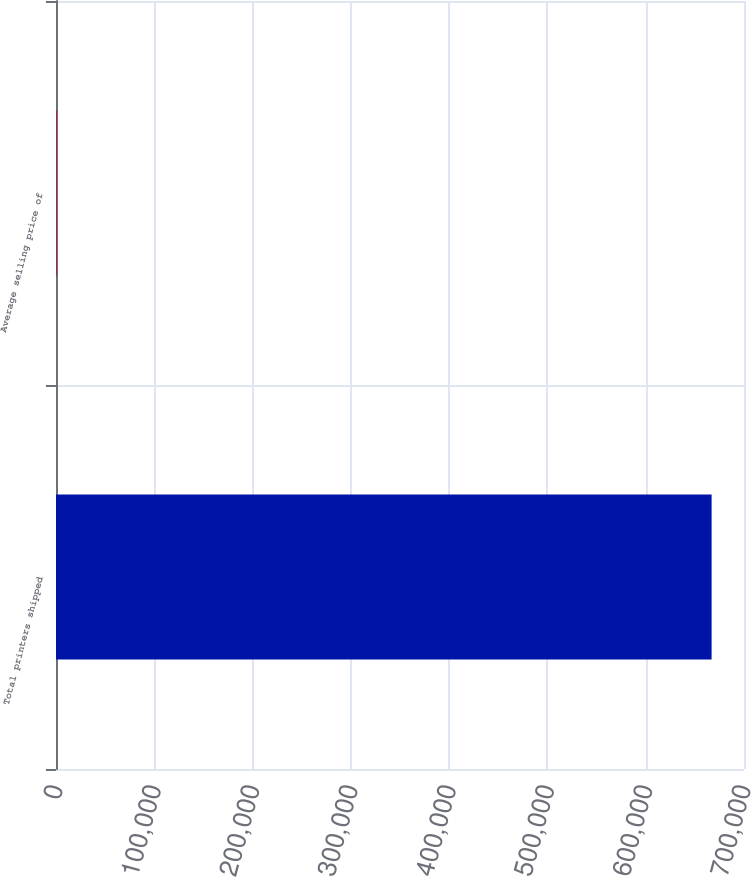<chart> <loc_0><loc_0><loc_500><loc_500><bar_chart><fcel>Total printers shipped<fcel>Average selling price of<nl><fcel>667044<fcel>646<nl></chart> 